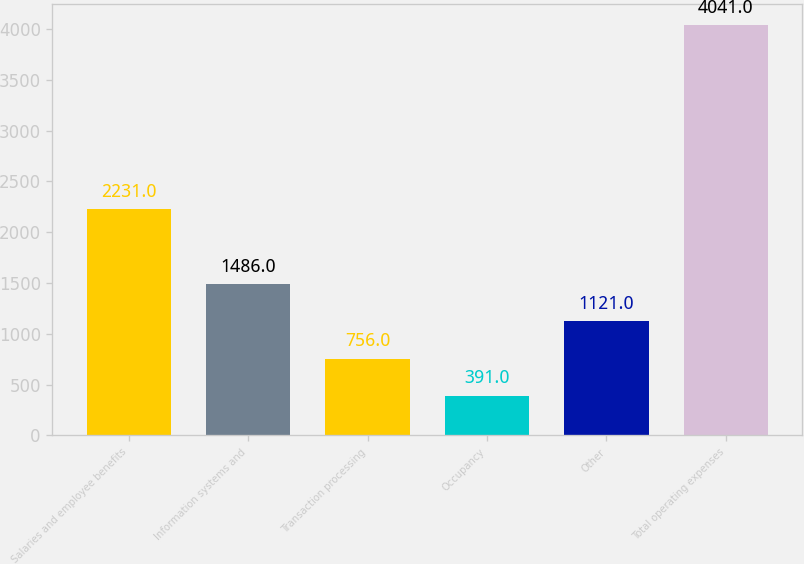Convert chart to OTSL. <chart><loc_0><loc_0><loc_500><loc_500><bar_chart><fcel>Salaries and employee benefits<fcel>Information systems and<fcel>Transaction processing<fcel>Occupancy<fcel>Other<fcel>Total operating expenses<nl><fcel>2231<fcel>1486<fcel>756<fcel>391<fcel>1121<fcel>4041<nl></chart> 